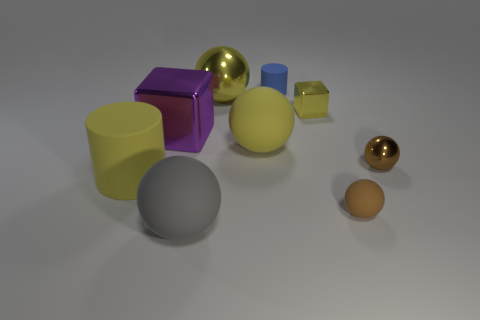The tiny cube is what color?
Ensure brevity in your answer.  Yellow. What number of rubber things are both in front of the large purple metallic thing and to the left of the tiny yellow shiny block?
Offer a terse response. 3. How many other objects are the same material as the yellow block?
Provide a short and direct response. 3. Are the large yellow sphere in front of the purple metal block and the gray sphere made of the same material?
Provide a succinct answer. Yes. There is a shiny object behind the yellow object that is to the right of the blue cylinder that is behind the small yellow cube; how big is it?
Keep it short and to the point. Large. How many other objects are there of the same color as the small shiny sphere?
Offer a very short reply. 1. There is a purple object that is the same size as the gray sphere; what is its shape?
Provide a succinct answer. Cube. What size is the matte cylinder behind the big yellow matte cylinder?
Your answer should be compact. Small. Do the metal sphere behind the tiny metallic ball and the cylinder that is on the left side of the large block have the same color?
Ensure brevity in your answer.  Yes. The tiny thing that is in front of the big yellow matte thing to the left of the big rubber ball behind the yellow cylinder is made of what material?
Keep it short and to the point. Rubber. 